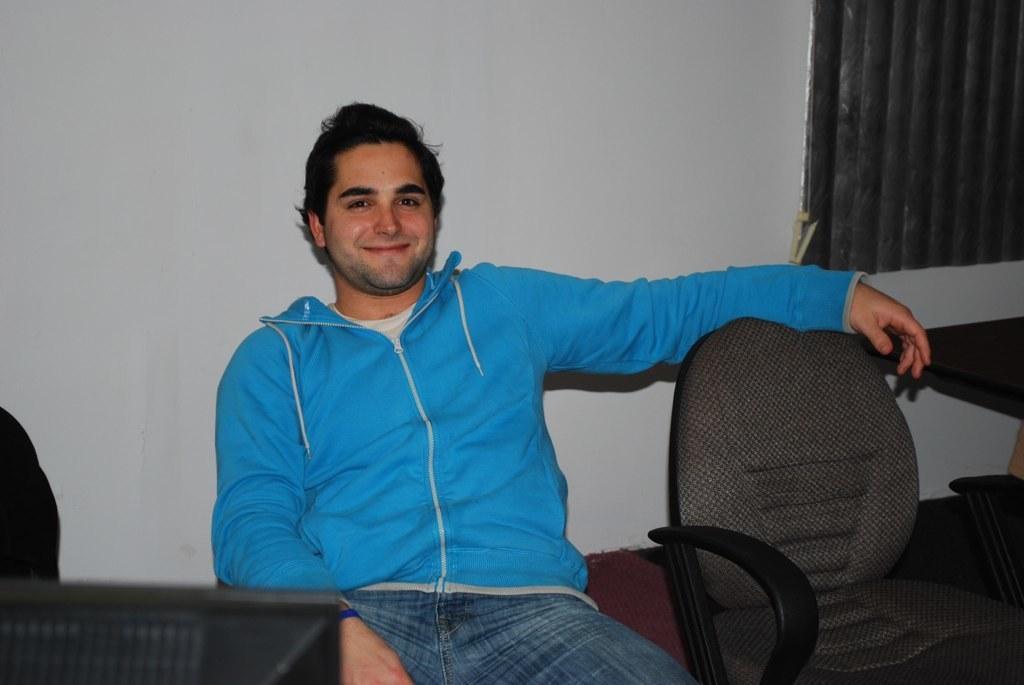How would you summarize this image in a sentence or two? In this image I can see a person is sitting on a chair. We can see another chair, table, wall and objects. 